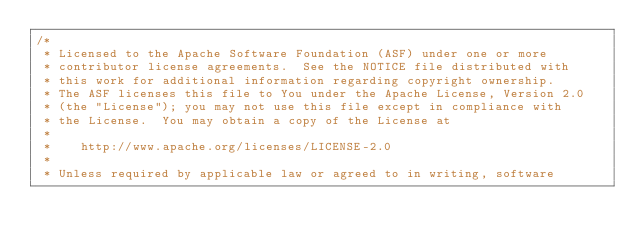<code> <loc_0><loc_0><loc_500><loc_500><_Java_>/*
 * Licensed to the Apache Software Foundation (ASF) under one or more
 * contributor license agreements.  See the NOTICE file distributed with
 * this work for additional information regarding copyright ownership.
 * The ASF licenses this file to You under the Apache License, Version 2.0
 * (the "License"); you may not use this file except in compliance with
 * the License.  You may obtain a copy of the License at
 *
 *    http://www.apache.org/licenses/LICENSE-2.0
 *
 * Unless required by applicable law or agreed to in writing, software</code> 